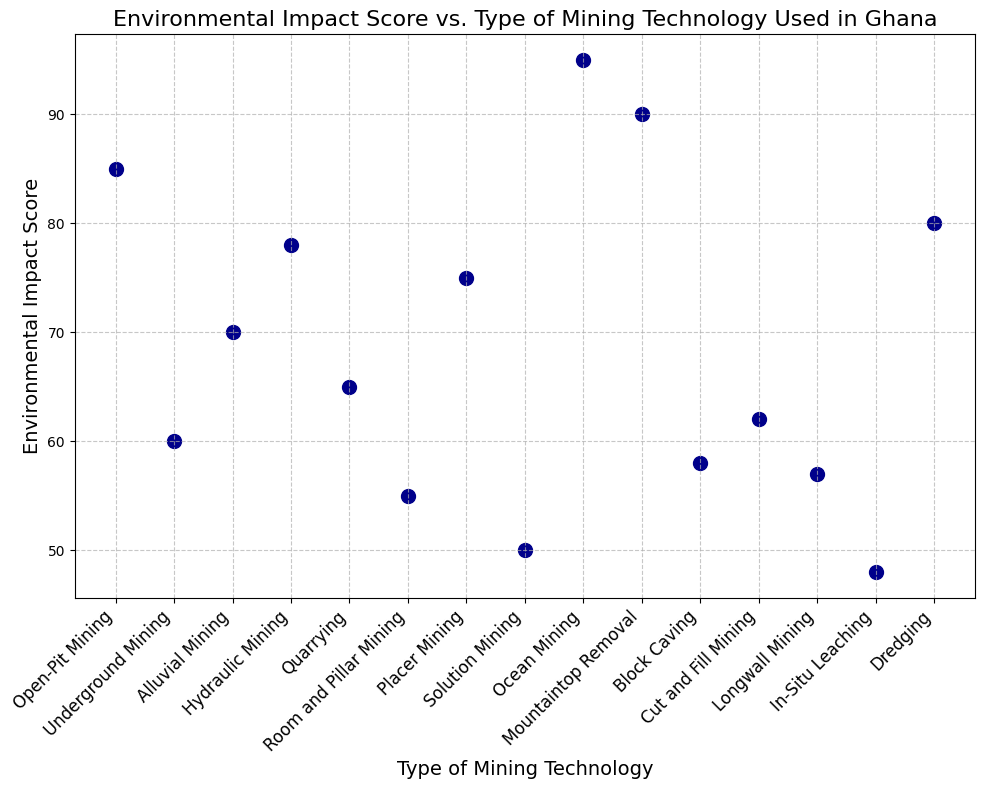Which type of mining technology has the lowest environmental impact score? Look at the scatter plot and identify the data point with the smallest y-axis value (Environmental Impact Score). In this case, it's "In-Situ Leaching" with a score of 48.
Answer: In-Situ Leaching Which type of mining technology has the highest environmental impact score? Check the scatter plot for the data point that has the highest position on the y-axis. This is "Ocean Mining" with a score of 95.
Answer: Ocean Mining What is the difference in environmental impact scores between Open-Pit Mining and Room and Pillar Mining? Find the y-axis values for both "Open-Pit Mining" and "Room and Pillar Mining" (85 and 55, respectively) and subtract the smaller value from the larger one: 85 - 55 = 30.
Answer: 30 Which mining technology has a higher environmental impact score: Quarrying or Block Caving? Compare the y-axis values for "Quarrying" (65) and "Block Caving" (58). Quarrying has the higher score.
Answer: Quarrying What is the average environmental impact score of all the mining technologies represented in the plot? Add up all the environmental impact scores (85, 60, 70, 78, 65, 55, 75, 50, 95, 90, 58, 62, 57, 48, 80) and divide by the number of data points (15). The sum is 928, and the average is 928 / 15 ≈ 61.87.
Answer: 61.87 Which mining technology has an environmental impact score closest to the median value of all the scores? Order the scores from smallest to largest: 48, 50, 55, 57, 58, 60, 62, 65, 70, 75, 78, 80, 85, 90, 95. The median score is the middle value, which is 65 (Quarrying).
Answer: Quarrying How many mining technologies have an environmental impact score greater than 70? Count the data points with y-axis values greater than 70: Open-Pit Mining (85), Hydraulic Mining (78), Ocean Mining (95), Mountaintop Removal (90), Placer Mining (75), and Dredging (80). There are 6 such technologies.
Answer: 6 What is the range of the environmental impact scores shown on the plot? The range is found by subtracting the smallest score from the largest score: 95 (Ocean Mining) - 48 (In-Situ Leaching) = 47.
Answer: 47 Which two mining technologies have the closest environmental impact scores, and what is the difference between them? Look for the smallest difference between adjacent scores. "Room and Pillar Mining" (55) and "Longwall Mining" (57) have the smallest difference: 57 - 55 = 2.
Answer: Room and Pillar Mining and Longwall Mining; 2 What is the sum of environmental impact scores for Underground Mining, Alluvial Mining, and Hydraulic Mining? Add their y-axis values: Underground Mining (60) + Alluvial Mining (70) + Hydraulic Mining (78) = 208.
Answer: 208 